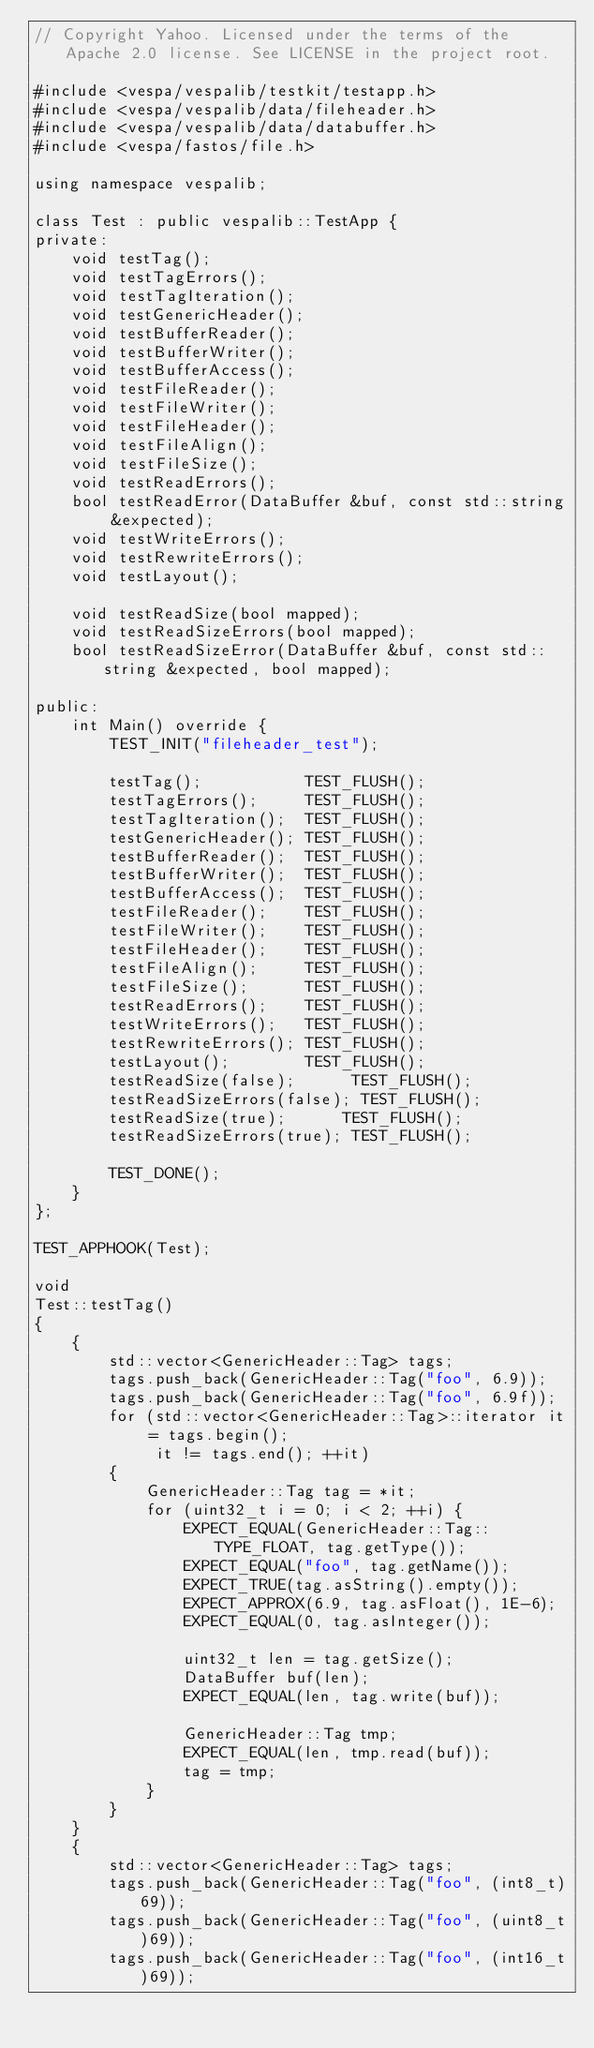<code> <loc_0><loc_0><loc_500><loc_500><_C++_>// Copyright Yahoo. Licensed under the terms of the Apache 2.0 license. See LICENSE in the project root.

#include <vespa/vespalib/testkit/testapp.h>
#include <vespa/vespalib/data/fileheader.h>
#include <vespa/vespalib/data/databuffer.h>
#include <vespa/fastos/file.h>

using namespace vespalib;

class Test : public vespalib::TestApp {
private:
    void testTag();
    void testTagErrors();
    void testTagIteration();
    void testGenericHeader();
    void testBufferReader();
    void testBufferWriter();
    void testBufferAccess();
    void testFileReader();
    void testFileWriter();
    void testFileHeader();
    void testFileAlign();
    void testFileSize();
    void testReadErrors();
    bool testReadError(DataBuffer &buf, const std::string &expected);
    void testWriteErrors();
    void testRewriteErrors();
    void testLayout();

    void testReadSize(bool mapped);
    void testReadSizeErrors(bool mapped);
    bool testReadSizeError(DataBuffer &buf, const std::string &expected, bool mapped);

public:
    int Main() override {
        TEST_INIT("fileheader_test");

        testTag();           TEST_FLUSH();
        testTagErrors();     TEST_FLUSH();
        testTagIteration();  TEST_FLUSH();
        testGenericHeader(); TEST_FLUSH();
        testBufferReader();  TEST_FLUSH();
        testBufferWriter();  TEST_FLUSH();
        testBufferAccess();  TEST_FLUSH();
        testFileReader();    TEST_FLUSH();
        testFileWriter();    TEST_FLUSH();
        testFileHeader();    TEST_FLUSH();
        testFileAlign();     TEST_FLUSH();
        testFileSize();      TEST_FLUSH();
        testReadErrors();    TEST_FLUSH();
        testWriteErrors();   TEST_FLUSH();
        testRewriteErrors(); TEST_FLUSH();
        testLayout();        TEST_FLUSH();
        testReadSize(false);      TEST_FLUSH();
        testReadSizeErrors(false); TEST_FLUSH();
        testReadSize(true);      TEST_FLUSH();
        testReadSizeErrors(true); TEST_FLUSH();

        TEST_DONE();
    }
};

TEST_APPHOOK(Test);

void
Test::testTag()
{
    {
        std::vector<GenericHeader::Tag> tags;
        tags.push_back(GenericHeader::Tag("foo", 6.9));
        tags.push_back(GenericHeader::Tag("foo", 6.9f));
        for (std::vector<GenericHeader::Tag>::iterator it = tags.begin();
             it != tags.end(); ++it)
        {
            GenericHeader::Tag tag = *it;
            for (uint32_t i = 0; i < 2; ++i) {
                EXPECT_EQUAL(GenericHeader::Tag::TYPE_FLOAT, tag.getType());
                EXPECT_EQUAL("foo", tag.getName());
                EXPECT_TRUE(tag.asString().empty());
                EXPECT_APPROX(6.9, tag.asFloat(), 1E-6);
                EXPECT_EQUAL(0, tag.asInteger());

                uint32_t len = tag.getSize();
                DataBuffer buf(len);
                EXPECT_EQUAL(len, tag.write(buf));

                GenericHeader::Tag tmp;
                EXPECT_EQUAL(len, tmp.read(buf));
                tag = tmp;
            }
        }
    }
    {
        std::vector<GenericHeader::Tag> tags;
        tags.push_back(GenericHeader::Tag("foo", (int8_t)69));
        tags.push_back(GenericHeader::Tag("foo", (uint8_t)69));
        tags.push_back(GenericHeader::Tag("foo", (int16_t)69));</code> 